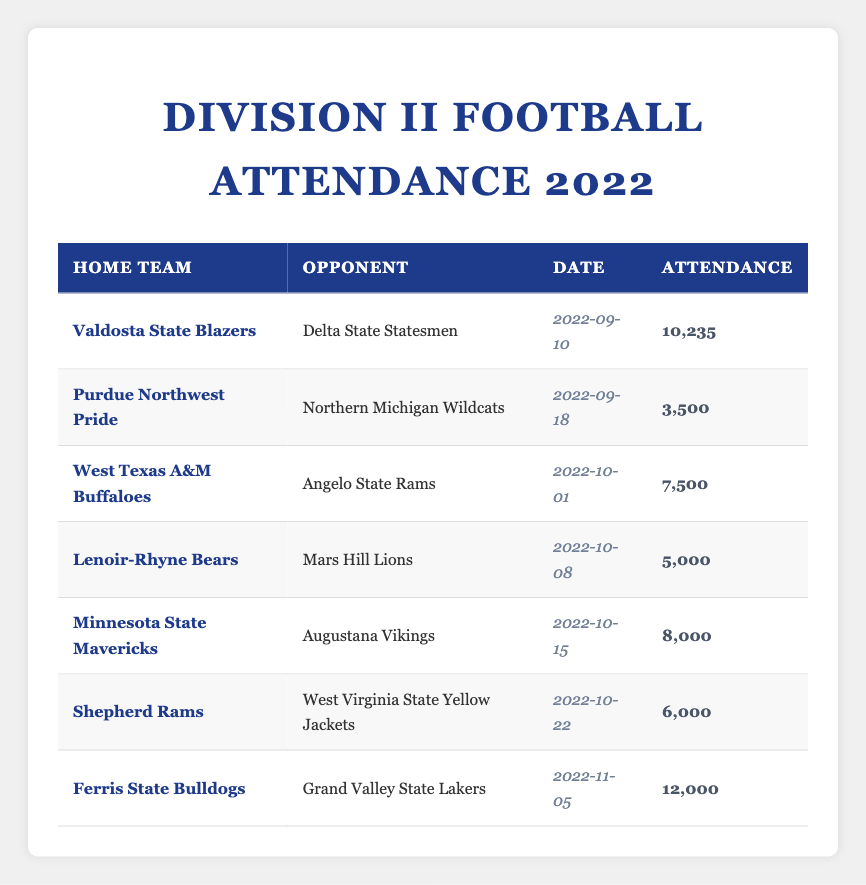What was the highest attendance figure recorded for a Division II football game in the 2022 season? The table shows attendance figures for various games. Scanning through the "Attendance" column, the highest value is 12000 for the game involving "Ferris State Bulldogs" with "Grand Valley State Lakers" on 2022-11-05.
Answer: 12000 Which team had the lowest attendance during a home game? The table lists attendance figures for different teams and their opponents. By looking at the "Attendance" column, the lowest figure is 3500, which corresponds to the "Purdue Northwest Pride" playing against the "Northern Michigan Wildcats" on 2022-09-18.
Answer: 3500 What is the total attendance across all games listed in the table? To find the total attendance, sum the attendance figures: 10235 + 3500 + 7500 + 5000 + 8000 + 6000 + 12000 =  10235 + 3500 + 7500 + 5000 + 8000 + 6000 + 12000 = 46000.
Answer: 46000 Did the "West Texas A&M Buffaloes" have more than 7000 attendees in their game? Checking the table, the attendance for "West Texas A&M Buffaloes" is listed as 7500, which is greater than 7000, confirming the statement is true.
Answer: Yes What was the average attendance at the games held on October 1st, October 8th, and October 15th? Looking specifically at the games on those dates, the attendances are 7500 (October 1), 5000 (October 8), and 8000 (October 15). Thus, calculate the average: (7500 + 5000 + 8000) / 3 = 20500 / 3 = 6833.33.
Answer: 6833.33 Which opponent did the "Shepherd Rams" face and what was their attendance figure? Referring to the row for "Shepherd Rams", their opponent is "West Virginia State Yellow Jackets" and the attendance figure recorded is 6000.
Answer: West Virginia State Yellow Jackets, 6000 How many teams had an attendance figure of more than 6000? From the attendance figures, the teams with attendances greater than 6000 are "Valdosta State Blazers" (10235), "West Texas A&M Buffaloes" (7500), "Minnesota State Mavericks" (8000), "Ferris State Bulldogs" (12000). There are four teams in total that fit this criterion.
Answer: 4 Was there any game played with an attendance below 4000? By reviewing the "Attendance" column, the lowest figure recorded is 3500 for "Purdue Northwest Pride", indicating that there was indeed a game played with an attendance below 4000.
Answer: Yes 